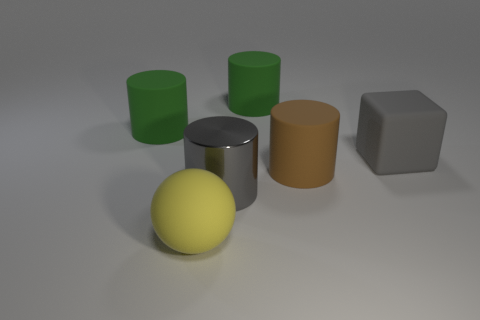Subtract all large rubber cylinders. How many cylinders are left? 1 Subtract all brown cylinders. How many cylinders are left? 3 Subtract all red cylinders. Subtract all yellow spheres. How many cylinders are left? 4 Add 4 red matte cylinders. How many objects exist? 10 Subtract all spheres. How many objects are left? 5 Add 3 rubber balls. How many rubber balls exist? 4 Subtract 0 purple cubes. How many objects are left? 6 Subtract all small cyan metal spheres. Subtract all gray metallic objects. How many objects are left? 5 Add 1 large green matte things. How many large green matte things are left? 3 